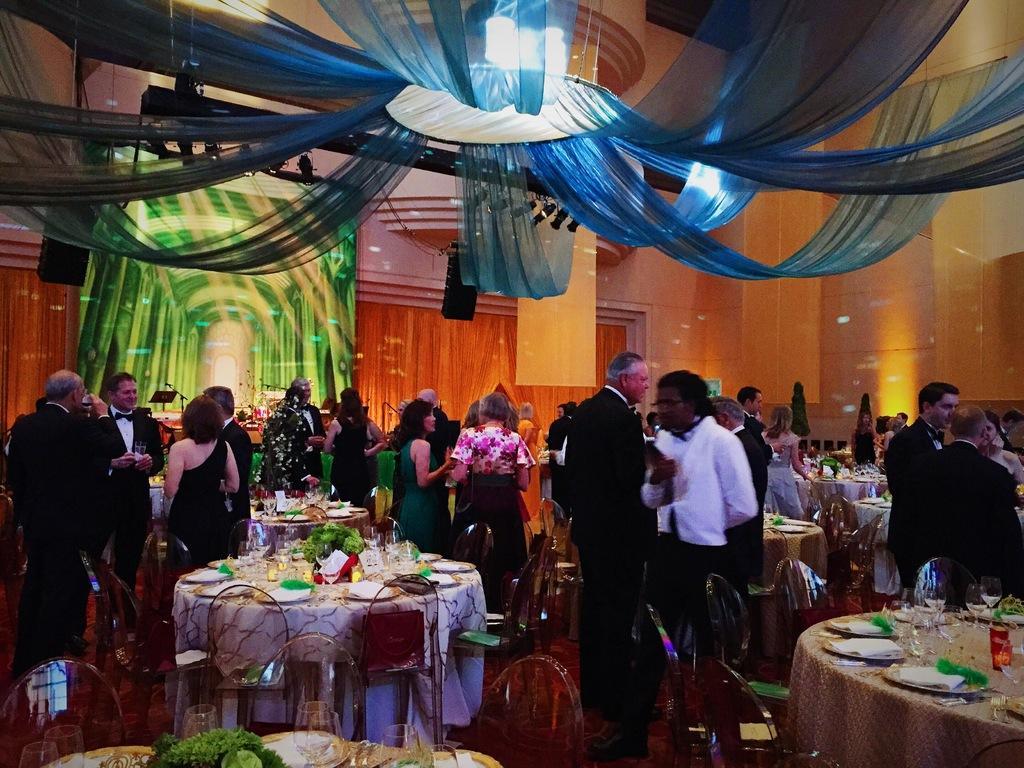Please provide a concise description of this image. This picture describes about group of people few are seated on the chair and few are standing, in front of them we can find couple of glasses, plates and a plant on the table, on top of them we can find couple of curtains and lights. 